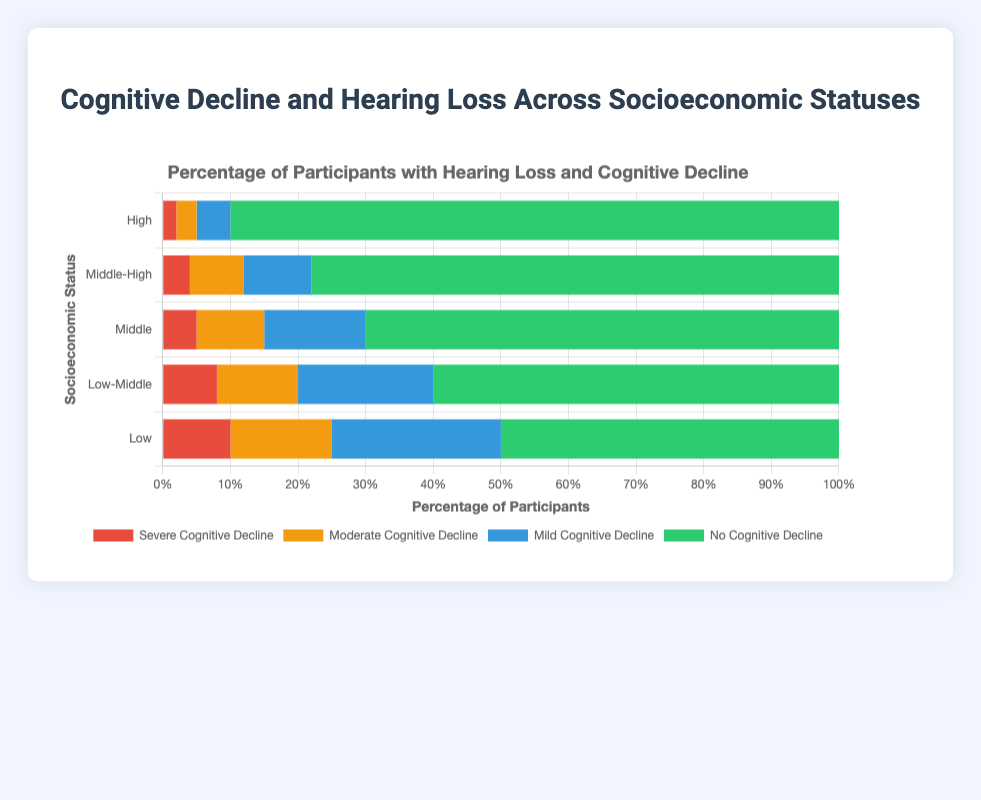Which socioeconomic status group has the highest percentage of participants with severe cognitive decline and hearing loss? The "Low" socioeconomic status group has the highest percentage of participants with severe cognitive decline and hearing loss at 10%.
Answer: Low Which socioeconomic status group has the lowest percentage of participants with no cognitive decline and hearing loss? The "Low" socioeconomic status group has the lowest percentage of participants with no cognitive decline and hearing loss at 50%.
Answer: Low What is the difference in percentage of participants with mild cognitive decline and hearing loss between the "Middle" and "Middle-High" socioeconomic status groups? The percentage of participants with mild cognitive decline and hearing loss in the "Middle" group is 15%, and in the "Middle-High" group, it is 10%. The difference is 15% - 10% = 5%.
Answer: 5% What is the total percentage of participants with cognitive decline and hearing loss in the "High" socioeconomic status group? The total percentage is the sum of participants with mild, moderate, and severe cognitive decline and hearing loss. So, 5% (mild) + 3% (moderate) + 2% (severe) = 10%.
Answer: 10% Between the "Low-Middle" and "Middle-High" socioeconomic status groups, which one has a higher percentage of participants with moderate cognitive decline and hearing loss, and by how much? The "Low-Middle" group has 12% with moderate cognitive decline and hearing loss, while the "Middle-High" group has 8%. The difference is 12% - 8% = 4%.
Answer: Low-Middle by 4% Which color represents the participants with no cognitive decline and hearing loss, and what does this indicate for the "High" socioeconomic status group? The green color represents participants with no cognitive decline and hearing loss. For the "High" socioeconomic status group, the green section is the largest, indicating 90% of participants have no cognitive decline and hearing loss.
Answer: Green, 90% What is the combined percentage of participants with moderate and severe cognitive decline and hearing loss in the "Middle" socioeconomic status group? For the "Middle" group, moderate is 10% and severe is 5%. The combined percentage is 10% + 5% = 15%.
Answer: 15% How does the percentage of participants with hearing loss and mild cognitive decline compare between the "High" and "Low" socioeconomic status groups? The "Low" socioeconomic status group has 25% of participants with mild cognitive decline and hearing loss, while the "High" group has only 5%. The "Low" group has a higher percentage by 20%.
Answer: Low by 20% Which socioeconomic status group has the largest combined percentage of participants with moderate and severe cognitive decline and hearing loss? The "Low" socioeconomic status group has 15% with moderate and 10% with severe cognitive decline and hearing loss. Combined, it is 15% + 10% = 25%, which is the largest among the groups.
Answer: Low What is the average percentage of participants with no cognitive decline and hearing loss across all socioeconomic status groups? The percentages are 50% (Low), 60% (Low-Middle), 70% (Middle), 78% (Middle-High), and 90% (High). The sum is 348%, divided by 5 groups, the average is 348 / 5 = 69.6%.
Answer: 69.6% 